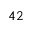<formula> <loc_0><loc_0><loc_500><loc_500>^ { 4 } 2</formula> 